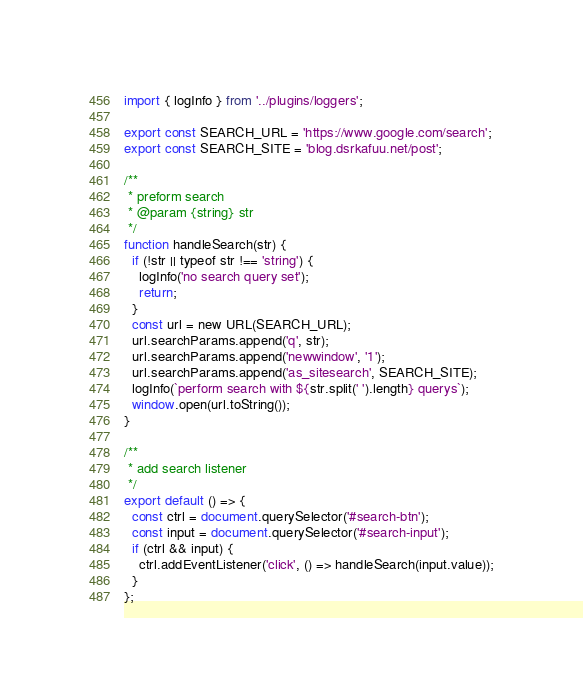Convert code to text. <code><loc_0><loc_0><loc_500><loc_500><_JavaScript_>import { logInfo } from '../plugins/loggers';

export const SEARCH_URL = 'https://www.google.com/search';
export const SEARCH_SITE = 'blog.dsrkafuu.net/post';

/**
 * preform search
 * @param {string} str
 */
function handleSearch(str) {
  if (!str || typeof str !== 'string') {
    logInfo('no search query set');
    return;
  }
  const url = new URL(SEARCH_URL);
  url.searchParams.append('q', str);
  url.searchParams.append('newwindow', '1');
  url.searchParams.append('as_sitesearch', SEARCH_SITE);
  logInfo(`perform search with ${str.split(' ').length} querys`);
  window.open(url.toString());
}

/**
 * add search listener
 */
export default () => {
  const ctrl = document.querySelector('#search-btn');
  const input = document.querySelector('#search-input');
  if (ctrl && input) {
    ctrl.addEventListener('click', () => handleSearch(input.value));
  }
};
</code> 